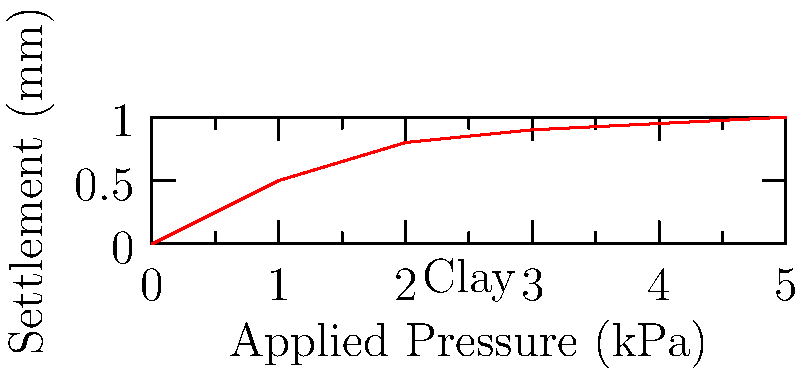As a clinical psychologist specializing in gastrointestinal diseases, you're collaborating on a study investigating the impact of building settlement on patient stress levels. The civil engineer provides you with a soil consolidation curve for a clay layer beneath a proposed medical facility. If the applied pressure from the building is 3 kPa, what is the expected settlement in millimeters? To determine the settlement at 3 kPa, we need to interpret the soil consolidation curve provided:

1. The x-axis represents the applied pressure in kPa.
2. The y-axis represents the settlement in mm.
3. We need to find the y-value (settlement) corresponding to an x-value (applied pressure) of 3 kPa.

Looking at the curve:

4. At x = 3 kPa, we can see that the curve intersects at approximately y = 0.9 mm.
5. This means that when 3 kPa of pressure is applied, the expected settlement is about 0.9 mm.

While this level of precision in soil mechanics might seem unusual for a psychologist, understanding the potential building movement can be crucial in assessing its impact on patient anxiety and stress levels, especially for those with gastrointestinal conditions who may be sensitive to environmental changes.
Answer: 0.9 mm 